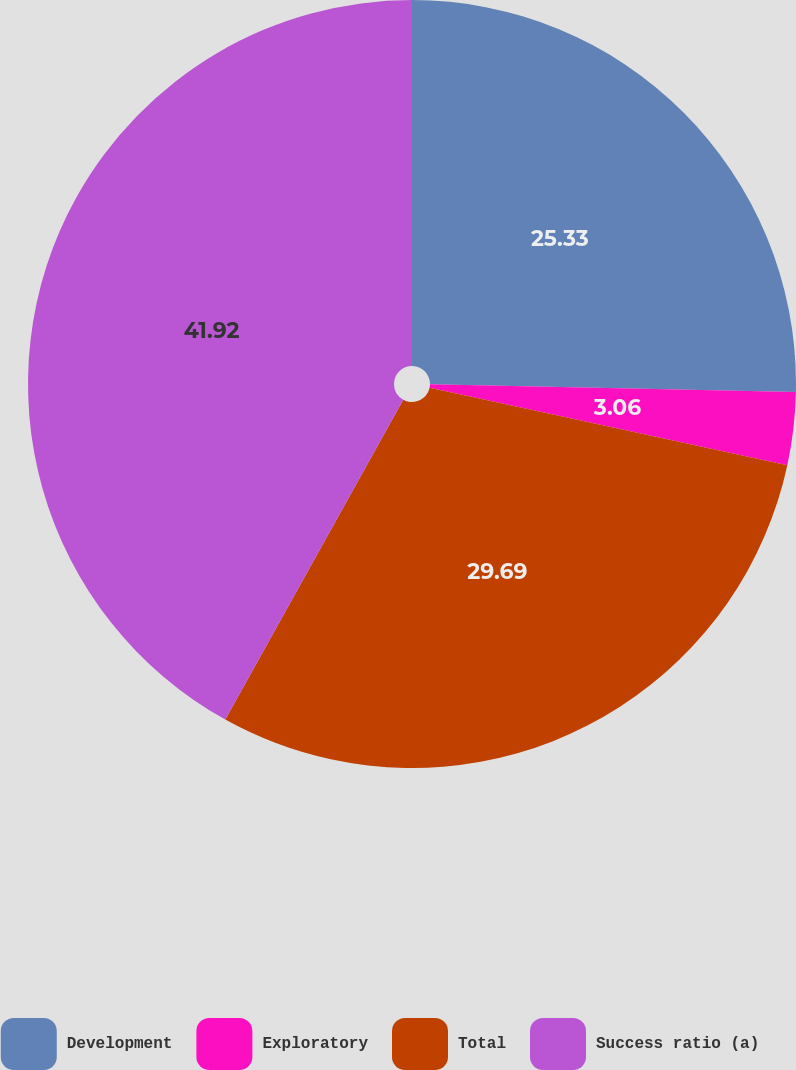Convert chart. <chart><loc_0><loc_0><loc_500><loc_500><pie_chart><fcel>Development<fcel>Exploratory<fcel>Total<fcel>Success ratio (a)<nl><fcel>25.33%<fcel>3.06%<fcel>29.69%<fcel>41.92%<nl></chart> 